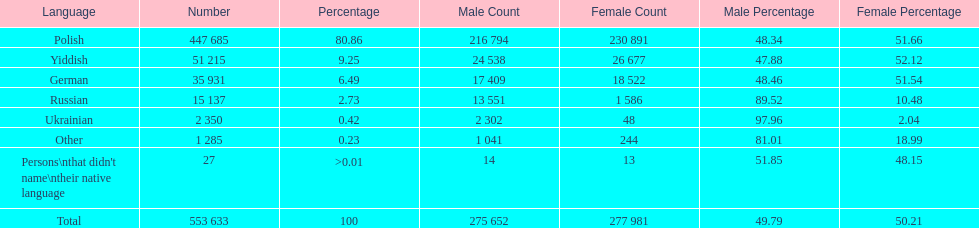How many male and female german speakers are there? 35931. 